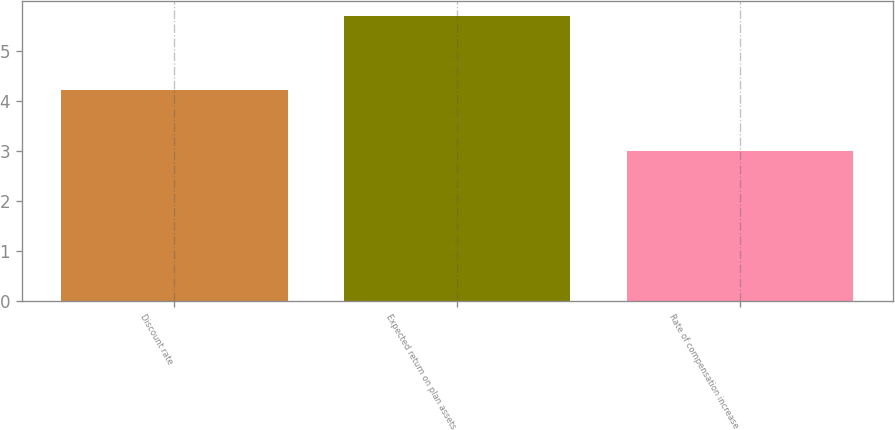Convert chart to OTSL. <chart><loc_0><loc_0><loc_500><loc_500><bar_chart><fcel>Discount rate<fcel>Expected return on plan assets<fcel>Rate of compensation increase<nl><fcel>4.21<fcel>5.7<fcel>3<nl></chart> 